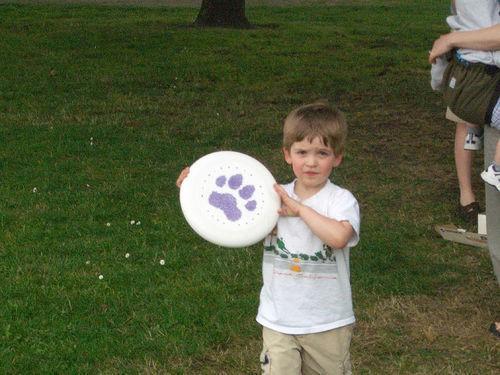How many people are there?
Give a very brief answer. 3. How many sheep can be seen?
Give a very brief answer. 0. 